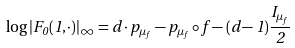Convert formula to latex. <formula><loc_0><loc_0><loc_500><loc_500>\log | F _ { 0 } ( 1 , \cdot ) | _ { \infty } = d \cdot p _ { \mu _ { f } } - p _ { \mu _ { f } } \circ f - ( d - 1 ) \frac { I _ { \mu _ { f } } } { 2 }</formula> 